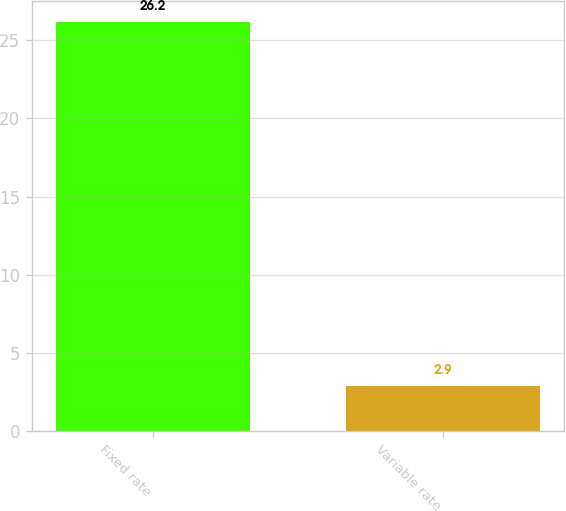Convert chart to OTSL. <chart><loc_0><loc_0><loc_500><loc_500><bar_chart><fcel>Fixed rate<fcel>Variable rate<nl><fcel>26.2<fcel>2.9<nl></chart> 